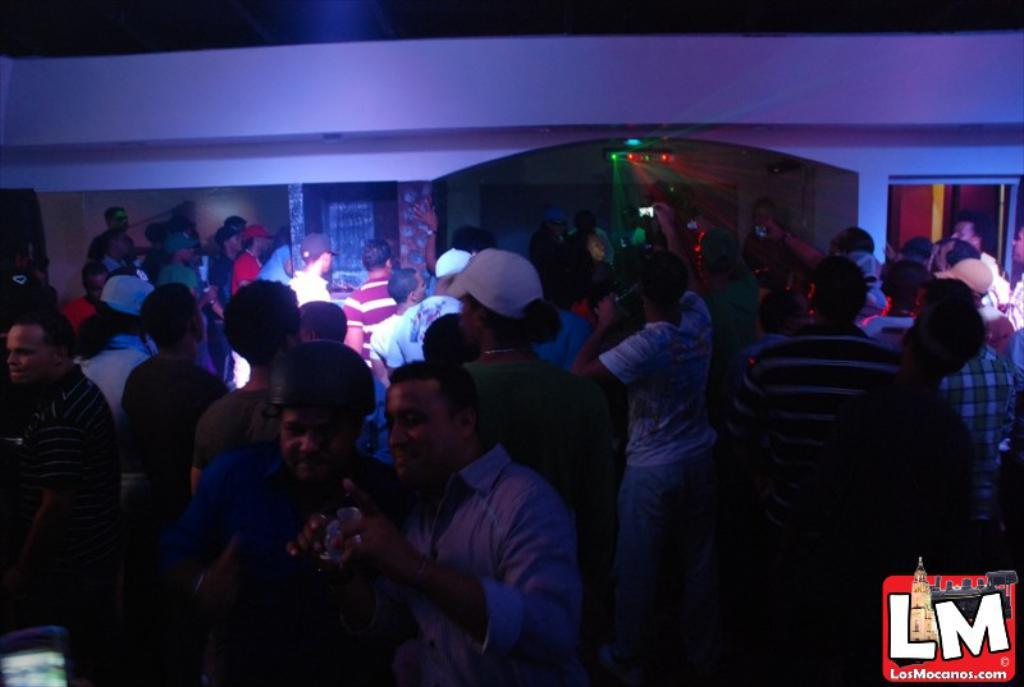Who or what is present in the image? There are people in the image. What can be seen in the image besides the people? There are lights visible in the image. Is there any text or logo in the image? Yes, there is a watermark in the bottom right corner of the image. How would you describe the lighting in the image? The bottom portion of the image is dark. What type of wine is being served on the sofa in the image? There is no wine or sofa present in the image. 